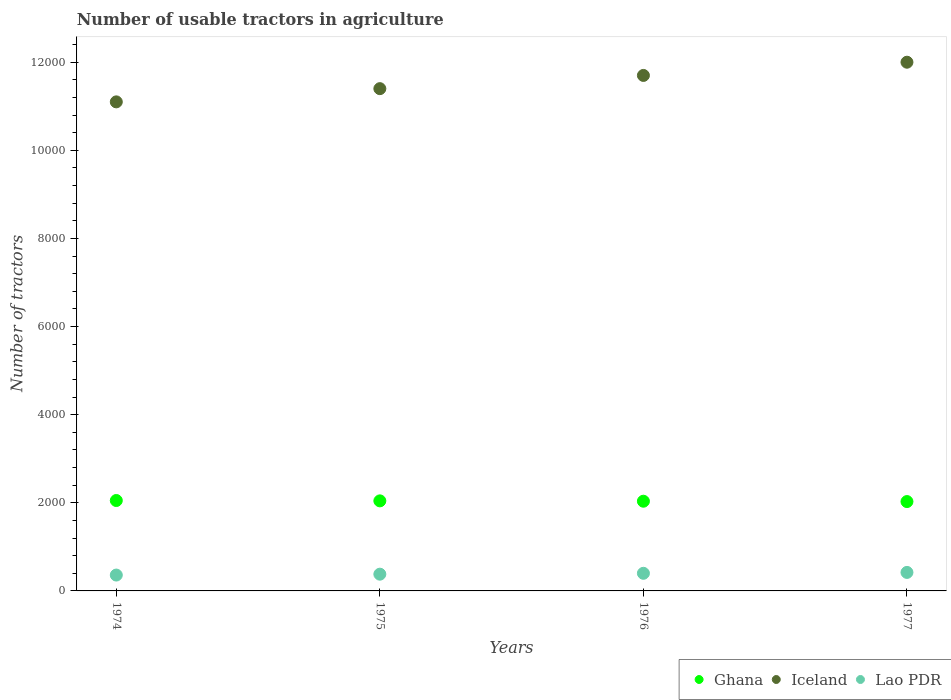Is the number of dotlines equal to the number of legend labels?
Your answer should be compact. Yes. What is the number of usable tractors in agriculture in Iceland in 1976?
Ensure brevity in your answer.  1.17e+04. Across all years, what is the maximum number of usable tractors in agriculture in Iceland?
Your answer should be compact. 1.20e+04. Across all years, what is the minimum number of usable tractors in agriculture in Lao PDR?
Give a very brief answer. 360. In which year was the number of usable tractors in agriculture in Ghana maximum?
Provide a short and direct response. 1974. In which year was the number of usable tractors in agriculture in Iceland minimum?
Your answer should be compact. 1974. What is the total number of usable tractors in agriculture in Ghana in the graph?
Keep it short and to the point. 8160. What is the difference between the number of usable tractors in agriculture in Ghana in 1974 and that in 1975?
Provide a succinct answer. 8. What is the difference between the number of usable tractors in agriculture in Ghana in 1975 and the number of usable tractors in agriculture in Iceland in 1974?
Your answer should be compact. -9056. What is the average number of usable tractors in agriculture in Iceland per year?
Ensure brevity in your answer.  1.16e+04. In the year 1974, what is the difference between the number of usable tractors in agriculture in Iceland and number of usable tractors in agriculture in Ghana?
Make the answer very short. 9048. What is the ratio of the number of usable tractors in agriculture in Ghana in 1974 to that in 1975?
Ensure brevity in your answer.  1. What is the difference between the highest and the lowest number of usable tractors in agriculture in Lao PDR?
Offer a very short reply. 60. In how many years, is the number of usable tractors in agriculture in Lao PDR greater than the average number of usable tractors in agriculture in Lao PDR taken over all years?
Provide a short and direct response. 2. Is the sum of the number of usable tractors in agriculture in Lao PDR in 1975 and 1976 greater than the maximum number of usable tractors in agriculture in Ghana across all years?
Keep it short and to the point. No. Is it the case that in every year, the sum of the number of usable tractors in agriculture in Iceland and number of usable tractors in agriculture in Ghana  is greater than the number of usable tractors in agriculture in Lao PDR?
Keep it short and to the point. Yes. Does the number of usable tractors in agriculture in Ghana monotonically increase over the years?
Ensure brevity in your answer.  No. How many dotlines are there?
Offer a terse response. 3. How many years are there in the graph?
Make the answer very short. 4. What is the difference between two consecutive major ticks on the Y-axis?
Provide a succinct answer. 2000. Does the graph contain any zero values?
Your answer should be compact. No. Does the graph contain grids?
Your response must be concise. No. How are the legend labels stacked?
Your response must be concise. Horizontal. What is the title of the graph?
Your answer should be very brief. Number of usable tractors in agriculture. What is the label or title of the X-axis?
Keep it short and to the point. Years. What is the label or title of the Y-axis?
Ensure brevity in your answer.  Number of tractors. What is the Number of tractors in Ghana in 1974?
Your answer should be very brief. 2052. What is the Number of tractors of Iceland in 1974?
Your answer should be very brief. 1.11e+04. What is the Number of tractors of Lao PDR in 1974?
Offer a terse response. 360. What is the Number of tractors in Ghana in 1975?
Keep it short and to the point. 2044. What is the Number of tractors of Iceland in 1975?
Your answer should be compact. 1.14e+04. What is the Number of tractors of Lao PDR in 1975?
Give a very brief answer. 380. What is the Number of tractors of Ghana in 1976?
Provide a succinct answer. 2036. What is the Number of tractors of Iceland in 1976?
Provide a short and direct response. 1.17e+04. What is the Number of tractors of Ghana in 1977?
Your answer should be compact. 2028. What is the Number of tractors in Iceland in 1977?
Keep it short and to the point. 1.20e+04. What is the Number of tractors in Lao PDR in 1977?
Provide a short and direct response. 420. Across all years, what is the maximum Number of tractors of Ghana?
Offer a terse response. 2052. Across all years, what is the maximum Number of tractors in Iceland?
Offer a terse response. 1.20e+04. Across all years, what is the maximum Number of tractors of Lao PDR?
Ensure brevity in your answer.  420. Across all years, what is the minimum Number of tractors of Ghana?
Ensure brevity in your answer.  2028. Across all years, what is the minimum Number of tractors in Iceland?
Offer a terse response. 1.11e+04. Across all years, what is the minimum Number of tractors in Lao PDR?
Give a very brief answer. 360. What is the total Number of tractors in Ghana in the graph?
Your answer should be compact. 8160. What is the total Number of tractors in Iceland in the graph?
Your answer should be very brief. 4.62e+04. What is the total Number of tractors of Lao PDR in the graph?
Keep it short and to the point. 1560. What is the difference between the Number of tractors of Iceland in 1974 and that in 1975?
Keep it short and to the point. -300. What is the difference between the Number of tractors in Iceland in 1974 and that in 1976?
Ensure brevity in your answer.  -600. What is the difference between the Number of tractors of Lao PDR in 1974 and that in 1976?
Keep it short and to the point. -40. What is the difference between the Number of tractors of Iceland in 1974 and that in 1977?
Provide a succinct answer. -900. What is the difference between the Number of tractors in Lao PDR in 1974 and that in 1977?
Provide a succinct answer. -60. What is the difference between the Number of tractors in Iceland in 1975 and that in 1976?
Offer a terse response. -300. What is the difference between the Number of tractors of Ghana in 1975 and that in 1977?
Give a very brief answer. 16. What is the difference between the Number of tractors of Iceland in 1975 and that in 1977?
Keep it short and to the point. -600. What is the difference between the Number of tractors of Lao PDR in 1975 and that in 1977?
Make the answer very short. -40. What is the difference between the Number of tractors of Ghana in 1976 and that in 1977?
Provide a short and direct response. 8. What is the difference between the Number of tractors in Iceland in 1976 and that in 1977?
Your answer should be compact. -300. What is the difference between the Number of tractors of Ghana in 1974 and the Number of tractors of Iceland in 1975?
Your answer should be very brief. -9348. What is the difference between the Number of tractors of Ghana in 1974 and the Number of tractors of Lao PDR in 1975?
Keep it short and to the point. 1672. What is the difference between the Number of tractors of Iceland in 1974 and the Number of tractors of Lao PDR in 1975?
Provide a short and direct response. 1.07e+04. What is the difference between the Number of tractors in Ghana in 1974 and the Number of tractors in Iceland in 1976?
Provide a succinct answer. -9648. What is the difference between the Number of tractors in Ghana in 1974 and the Number of tractors in Lao PDR in 1976?
Ensure brevity in your answer.  1652. What is the difference between the Number of tractors of Iceland in 1974 and the Number of tractors of Lao PDR in 1976?
Give a very brief answer. 1.07e+04. What is the difference between the Number of tractors in Ghana in 1974 and the Number of tractors in Iceland in 1977?
Provide a succinct answer. -9948. What is the difference between the Number of tractors of Ghana in 1974 and the Number of tractors of Lao PDR in 1977?
Give a very brief answer. 1632. What is the difference between the Number of tractors in Iceland in 1974 and the Number of tractors in Lao PDR in 1977?
Your answer should be compact. 1.07e+04. What is the difference between the Number of tractors of Ghana in 1975 and the Number of tractors of Iceland in 1976?
Make the answer very short. -9656. What is the difference between the Number of tractors in Ghana in 1975 and the Number of tractors in Lao PDR in 1976?
Provide a succinct answer. 1644. What is the difference between the Number of tractors of Iceland in 1975 and the Number of tractors of Lao PDR in 1976?
Ensure brevity in your answer.  1.10e+04. What is the difference between the Number of tractors in Ghana in 1975 and the Number of tractors in Iceland in 1977?
Keep it short and to the point. -9956. What is the difference between the Number of tractors of Ghana in 1975 and the Number of tractors of Lao PDR in 1977?
Your answer should be very brief. 1624. What is the difference between the Number of tractors in Iceland in 1975 and the Number of tractors in Lao PDR in 1977?
Your answer should be compact. 1.10e+04. What is the difference between the Number of tractors of Ghana in 1976 and the Number of tractors of Iceland in 1977?
Offer a terse response. -9964. What is the difference between the Number of tractors of Ghana in 1976 and the Number of tractors of Lao PDR in 1977?
Keep it short and to the point. 1616. What is the difference between the Number of tractors of Iceland in 1976 and the Number of tractors of Lao PDR in 1977?
Your answer should be compact. 1.13e+04. What is the average Number of tractors in Ghana per year?
Keep it short and to the point. 2040. What is the average Number of tractors of Iceland per year?
Your response must be concise. 1.16e+04. What is the average Number of tractors in Lao PDR per year?
Your answer should be compact. 390. In the year 1974, what is the difference between the Number of tractors of Ghana and Number of tractors of Iceland?
Offer a terse response. -9048. In the year 1974, what is the difference between the Number of tractors in Ghana and Number of tractors in Lao PDR?
Give a very brief answer. 1692. In the year 1974, what is the difference between the Number of tractors of Iceland and Number of tractors of Lao PDR?
Your answer should be very brief. 1.07e+04. In the year 1975, what is the difference between the Number of tractors in Ghana and Number of tractors in Iceland?
Your answer should be very brief. -9356. In the year 1975, what is the difference between the Number of tractors of Ghana and Number of tractors of Lao PDR?
Offer a very short reply. 1664. In the year 1975, what is the difference between the Number of tractors in Iceland and Number of tractors in Lao PDR?
Offer a very short reply. 1.10e+04. In the year 1976, what is the difference between the Number of tractors in Ghana and Number of tractors in Iceland?
Keep it short and to the point. -9664. In the year 1976, what is the difference between the Number of tractors of Ghana and Number of tractors of Lao PDR?
Ensure brevity in your answer.  1636. In the year 1976, what is the difference between the Number of tractors in Iceland and Number of tractors in Lao PDR?
Your response must be concise. 1.13e+04. In the year 1977, what is the difference between the Number of tractors of Ghana and Number of tractors of Iceland?
Your answer should be compact. -9972. In the year 1977, what is the difference between the Number of tractors in Ghana and Number of tractors in Lao PDR?
Provide a short and direct response. 1608. In the year 1977, what is the difference between the Number of tractors in Iceland and Number of tractors in Lao PDR?
Your response must be concise. 1.16e+04. What is the ratio of the Number of tractors of Ghana in 1974 to that in 1975?
Offer a terse response. 1. What is the ratio of the Number of tractors of Iceland in 1974 to that in 1975?
Your answer should be compact. 0.97. What is the ratio of the Number of tractors of Lao PDR in 1974 to that in 1975?
Ensure brevity in your answer.  0.95. What is the ratio of the Number of tractors in Ghana in 1974 to that in 1976?
Offer a terse response. 1.01. What is the ratio of the Number of tractors in Iceland in 1974 to that in 1976?
Offer a terse response. 0.95. What is the ratio of the Number of tractors of Lao PDR in 1974 to that in 1976?
Make the answer very short. 0.9. What is the ratio of the Number of tractors of Ghana in 1974 to that in 1977?
Your response must be concise. 1.01. What is the ratio of the Number of tractors in Iceland in 1974 to that in 1977?
Your answer should be compact. 0.93. What is the ratio of the Number of tractors in Ghana in 1975 to that in 1976?
Offer a very short reply. 1. What is the ratio of the Number of tractors in Iceland in 1975 to that in 1976?
Your answer should be compact. 0.97. What is the ratio of the Number of tractors in Ghana in 1975 to that in 1977?
Provide a succinct answer. 1.01. What is the ratio of the Number of tractors in Lao PDR in 1975 to that in 1977?
Make the answer very short. 0.9. What is the ratio of the Number of tractors of Lao PDR in 1976 to that in 1977?
Your answer should be very brief. 0.95. What is the difference between the highest and the second highest Number of tractors of Ghana?
Offer a very short reply. 8. What is the difference between the highest and the second highest Number of tractors in Iceland?
Give a very brief answer. 300. What is the difference between the highest and the lowest Number of tractors of Iceland?
Offer a very short reply. 900. What is the difference between the highest and the lowest Number of tractors in Lao PDR?
Ensure brevity in your answer.  60. 